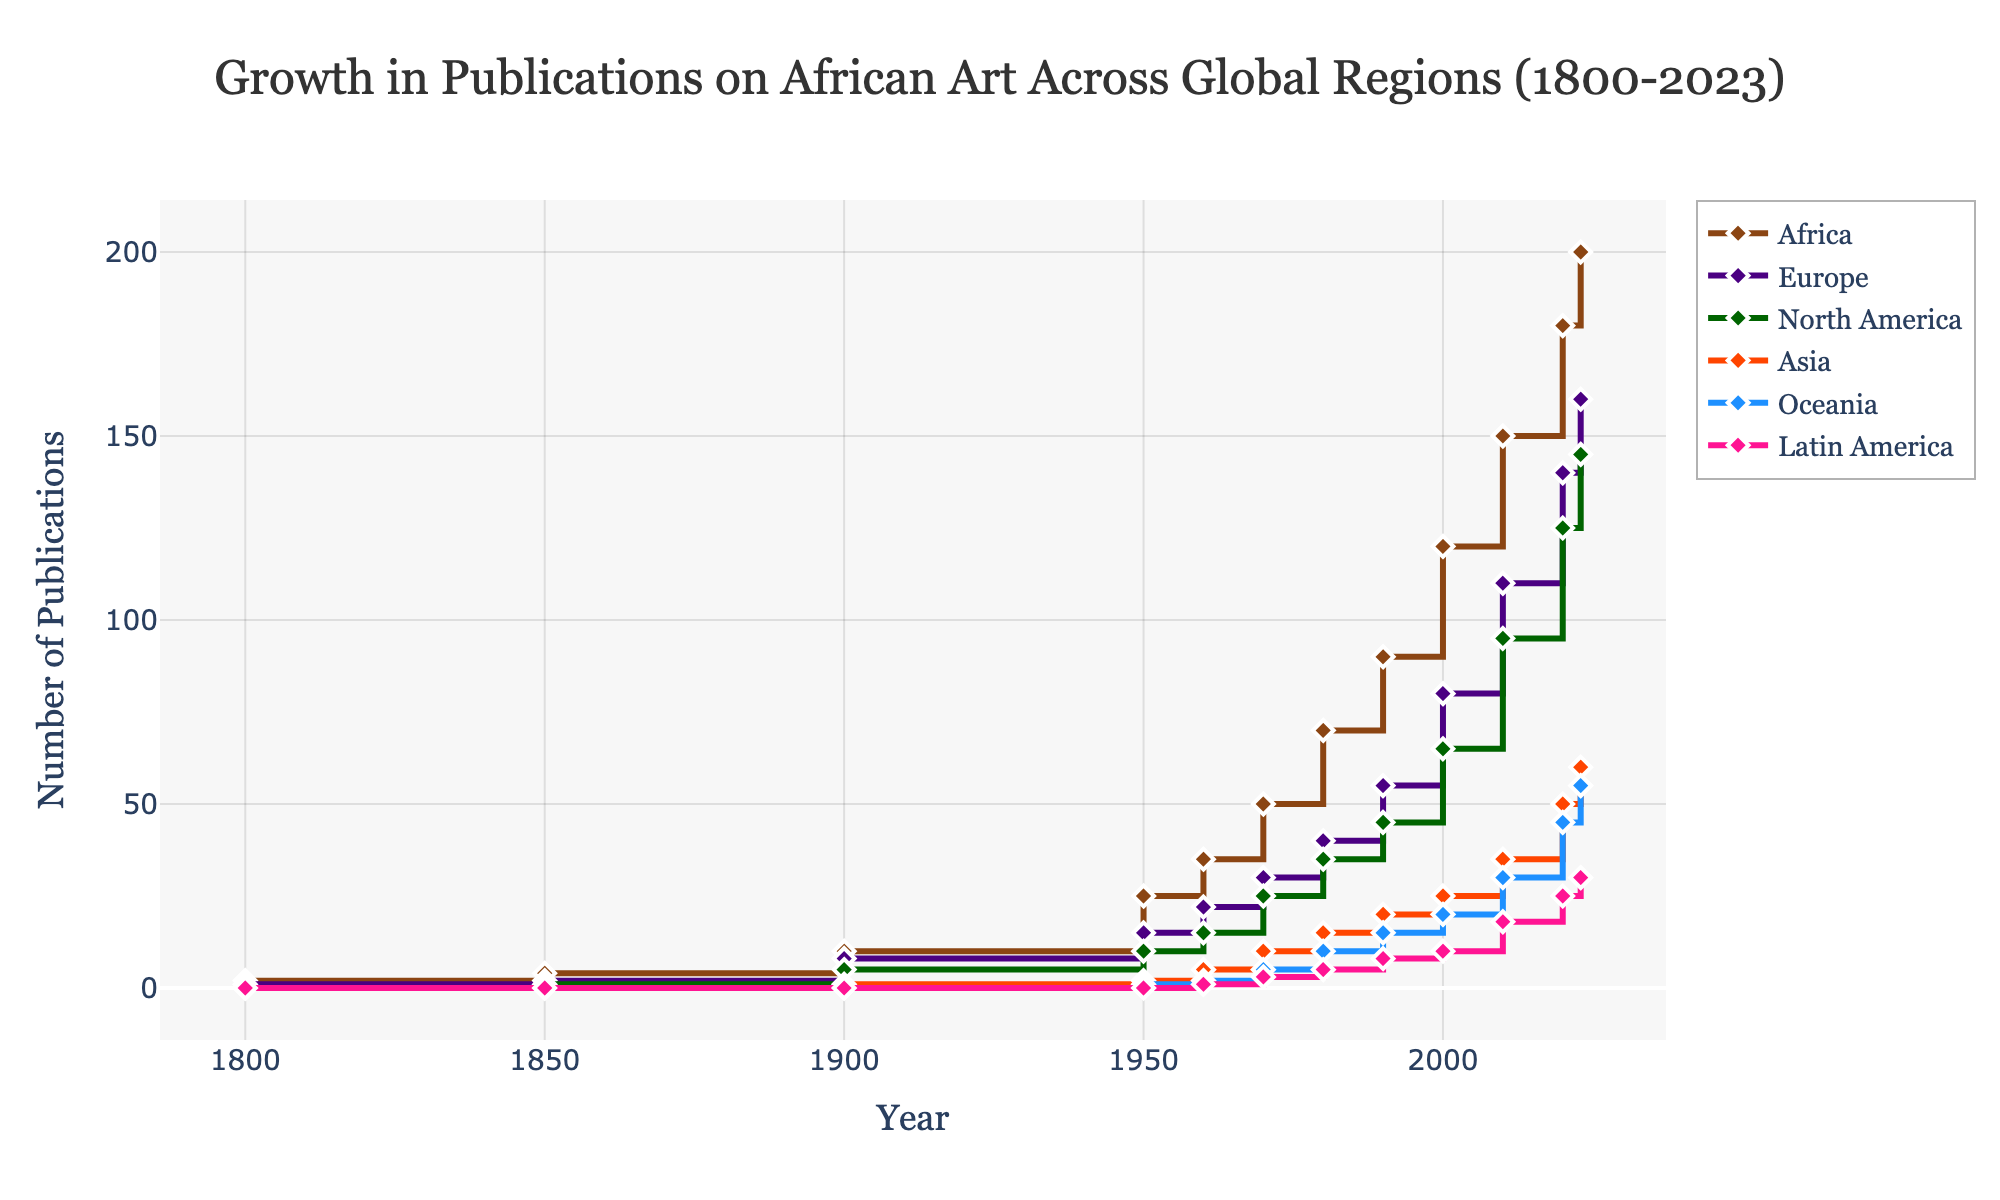What's the title of the plot? The title of a plot is usually displayed at the top and provides a brief description of what the plot represents. In this case, the title would be located at the top center of the figure.
Answer: Growth in Publications on African Art Across Global Regions (1800-2023) What is the value of publications on African art in Africa in 1850? First, find the data point for the year 1850 on the x-axis. Then trace upwards to find the corresponding value on the y-axis for the 'Africa' line.
Answer: 4 Between 1900 and 1950, by how much did the number of publications on African art increase in Europe? Find the publication numbers for Europe in 1900 and 1950, which are 8 and 15, respectively. Subtract the value in 1900 from the value in 1950 to get the increase: 15 - 8 = 7.
Answer: 7 Which region saw the largest growth in publications from 1990 to 2020? Identify publication numbers for each region in 1990 and 2020, then calculate the differences: Africa (180-90=90), Europe (140-55=85), North America (125-45=80), Asia (50-20=30), Oceania (45-15=30), Latin America (25-8=17). Africa had the largest increase.
Answer: Africa What’s the trend of publications on African art in Oceania from 1980 to 2023? Trace the data points for Oceania from 1980 to 2023 on the plot. The number of publications steadily increases from 10 in 1980 to 55 in 2023.
Answer: Steady increase By how much did the combined number of publications in Asia and Oceania grow from 1970 to 2000? For Asia: 25 (2000) - 10 (1970) = 15. For Oceania: 20 (2000) - 5 (1970) = 15. Combined: 15 + 15 = 30.
Answer: 30 Which regions first reached more than 100 publications and in which years? Find the years where the publication numbers surpassed 100 for each region. Africa did so in 2000 (120), Europe in 2020 (140), North America in 2010 (110). No other regions surpassed 100 by 2023.
Answer: Africa (2000), North America (2010), Europe (2020) In what year did North America have 95 publications and how many did Asia have in the same year? First, locate North America’s 95 publications in 2010, then check the value for Asia in 2010, which is 35.
Answer: 2010, 35 Which two regions had the closest publication numbers in 2023, and what were they? Compare the 2023 publication numbers for each pair of regions: Africa (200), Europe (160), North America (145), Asia (60), Oceania (55), Latin America (30). The closest pair is Asia (60) and Oceania (55).
Answer: Asia and Oceania, 60 and 55 